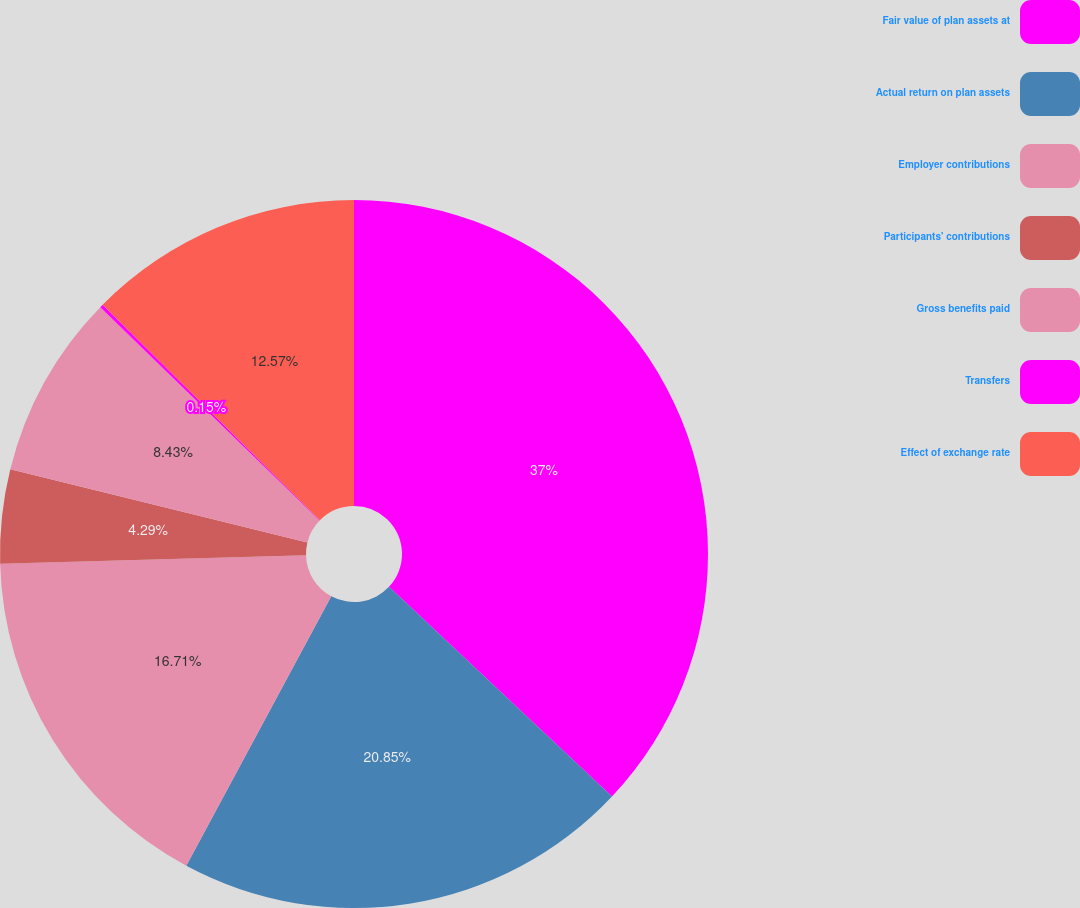Convert chart. <chart><loc_0><loc_0><loc_500><loc_500><pie_chart><fcel>Fair value of plan assets at<fcel>Actual return on plan assets<fcel>Employer contributions<fcel>Participants' contributions<fcel>Gross benefits paid<fcel>Transfers<fcel>Effect of exchange rate<nl><fcel>37.01%<fcel>20.85%<fcel>16.71%<fcel>4.29%<fcel>8.43%<fcel>0.15%<fcel>12.57%<nl></chart> 